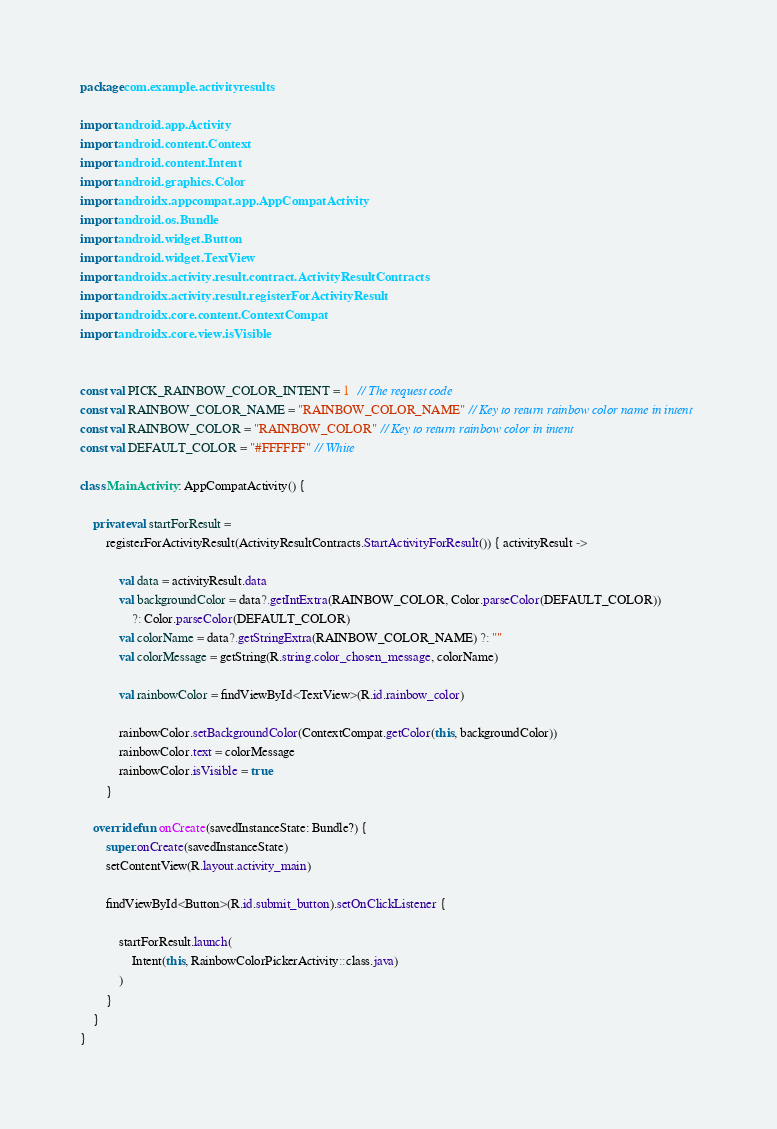<code> <loc_0><loc_0><loc_500><loc_500><_Kotlin_>package com.example.activityresults

import android.app.Activity
import android.content.Context
import android.content.Intent
import android.graphics.Color
import androidx.appcompat.app.AppCompatActivity
import android.os.Bundle
import android.widget.Button
import android.widget.TextView
import androidx.activity.result.contract.ActivityResultContracts
import androidx.activity.result.registerForActivityResult
import androidx.core.content.ContextCompat
import androidx.core.view.isVisible


const val PICK_RAINBOW_COLOR_INTENT = 1  // The request code
const val RAINBOW_COLOR_NAME = "RAINBOW_COLOR_NAME" // Key to return rainbow color name in intent
const val RAINBOW_COLOR = "RAINBOW_COLOR" // Key to return rainbow color in intent
const val DEFAULT_COLOR = "#FFFFFF" // White

class MainActivity : AppCompatActivity() {

    private val startForResult =
        registerForActivityResult(ActivityResultContracts.StartActivityForResult()) { activityResult ->

            val data = activityResult.data
            val backgroundColor = data?.getIntExtra(RAINBOW_COLOR, Color.parseColor(DEFAULT_COLOR))
                ?: Color.parseColor(DEFAULT_COLOR)
            val colorName = data?.getStringExtra(RAINBOW_COLOR_NAME) ?: ""
            val colorMessage = getString(R.string.color_chosen_message, colorName)

            val rainbowColor = findViewById<TextView>(R.id.rainbow_color)

            rainbowColor.setBackgroundColor(ContextCompat.getColor(this, backgroundColor))
            rainbowColor.text = colorMessage
            rainbowColor.isVisible = true
        }

    override fun onCreate(savedInstanceState: Bundle?) {
        super.onCreate(savedInstanceState)
        setContentView(R.layout.activity_main)

        findViewById<Button>(R.id.submit_button).setOnClickListener {

            startForResult.launch(
                Intent(this, RainbowColorPickerActivity::class.java)
            )
        }
    }
}
</code> 